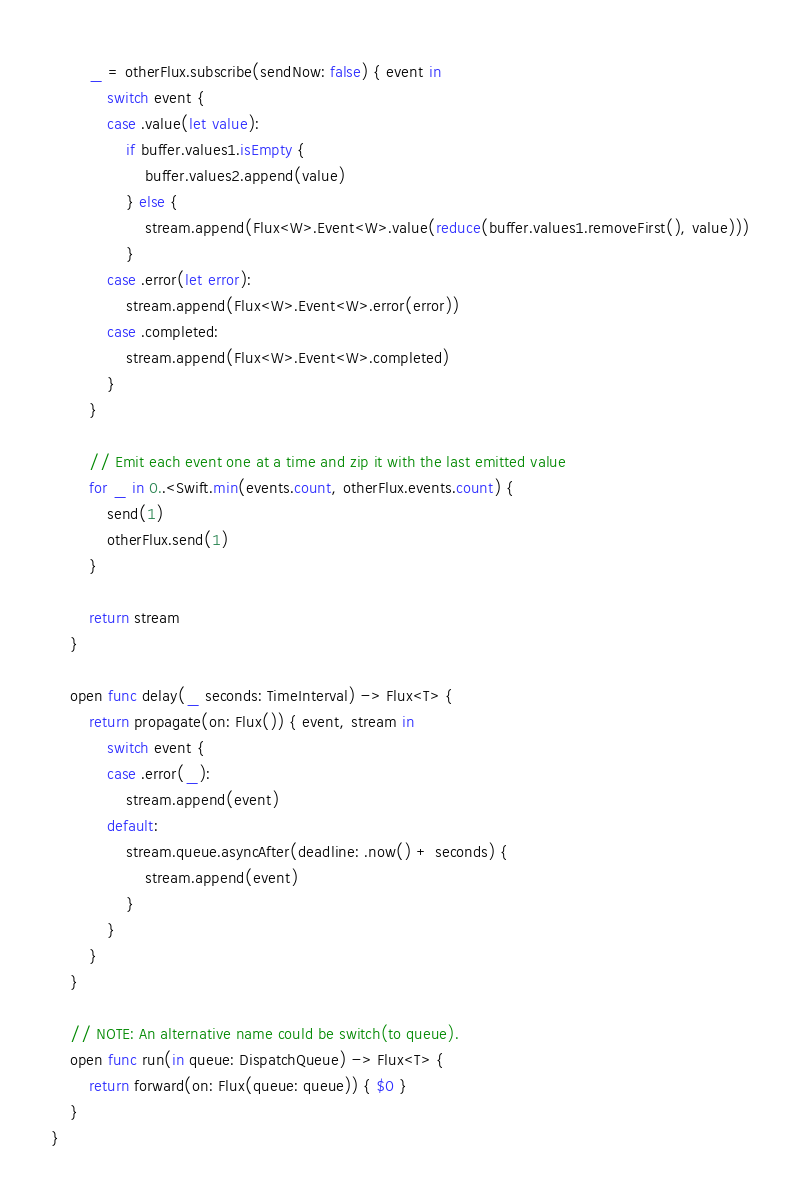<code> <loc_0><loc_0><loc_500><loc_500><_Swift_>		_ = otherFlux.subscribe(sendNow: false) { event in
			switch event {
            case .value(let value):
				if buffer.values1.isEmpty {
					buffer.values2.append(value)
				} else {
					stream.append(Flux<W>.Event<W>.value(reduce(buffer.values1.removeFirst(), value)))
				}
            case .error(let error):
                stream.append(Flux<W>.Event<W>.error(error))
            case .completed:
                stream.append(Flux<W>.Event<W>.completed)
            }
		}

		// Emit each event one at a time and zip it with the last emitted value
		for _ in 0..<Swift.min(events.count, otherFlux.events.count) {
			send(1)
			otherFlux.send(1)
		}

        return stream
    }
	
	open func delay(_ seconds: TimeInterval) -> Flux<T> {
		return propagate(on: Flux()) { event, stream in
			switch event {
			case .error(_):
				stream.append(event)
			default:
				stream.queue.asyncAfter(deadline: .now() + seconds) {
					stream.append(event)
				}
			}
		}
	}

	// NOTE: An alternative name could be switch(to queue).
	open func run(in queue: DispatchQueue) -> Flux<T> {
		return forward(on: Flux(queue: queue)) { $0 }
	}
}
</code> 